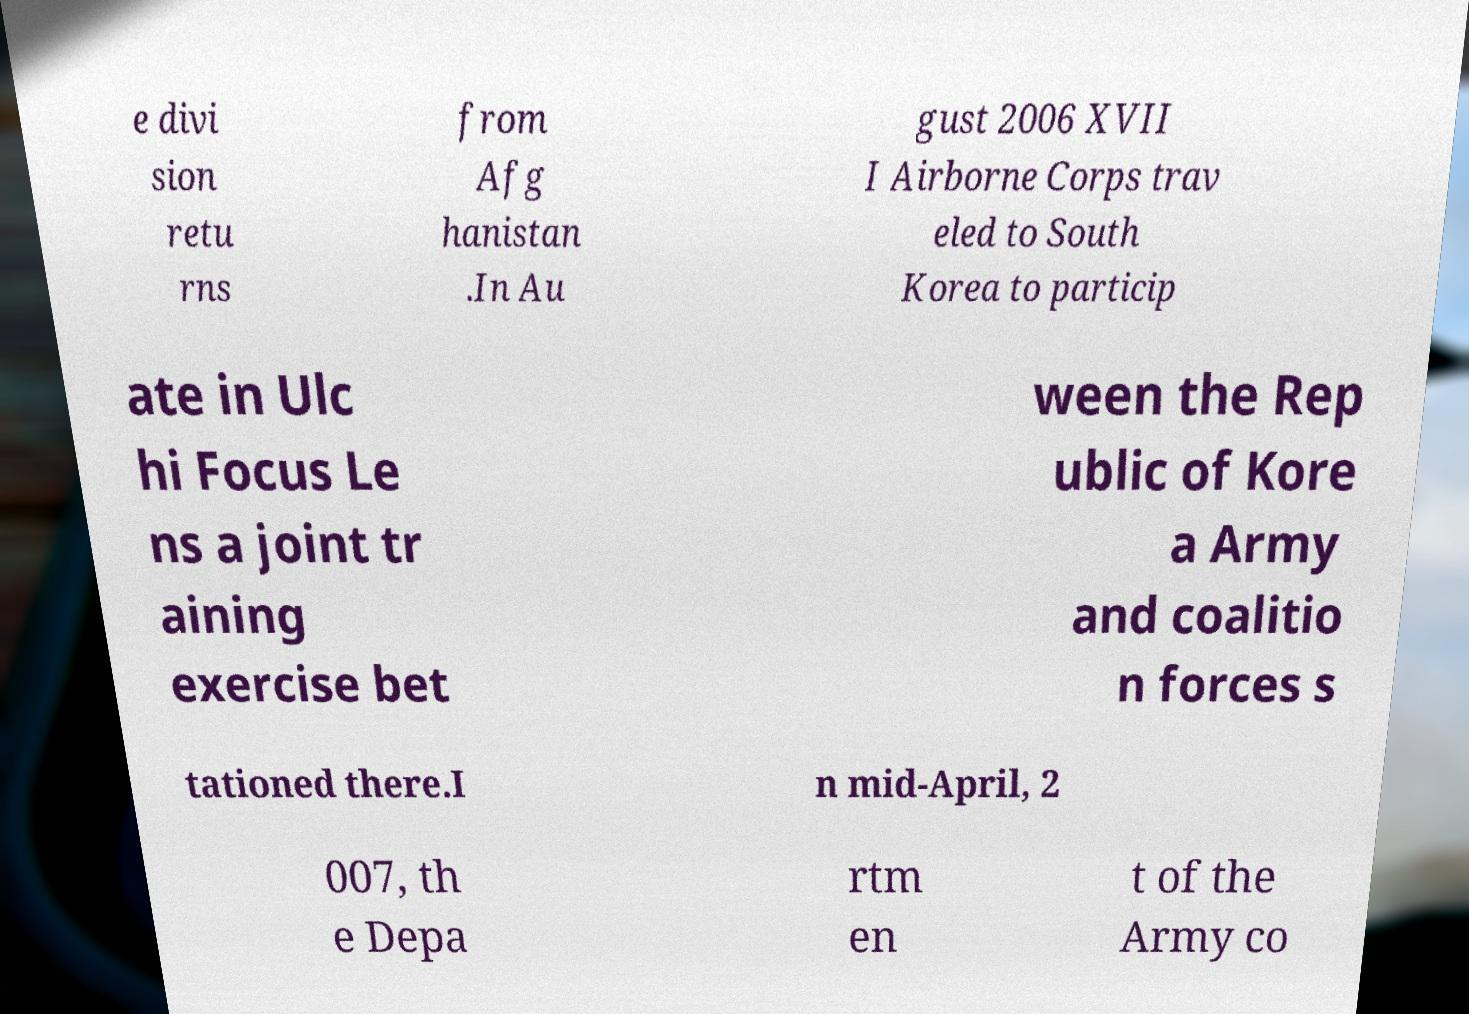There's text embedded in this image that I need extracted. Can you transcribe it verbatim? e divi sion retu rns from Afg hanistan .In Au gust 2006 XVII I Airborne Corps trav eled to South Korea to particip ate in Ulc hi Focus Le ns a joint tr aining exercise bet ween the Rep ublic of Kore a Army and coalitio n forces s tationed there.I n mid-April, 2 007, th e Depa rtm en t of the Army co 